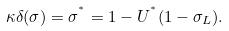Convert formula to latex. <formula><loc_0><loc_0><loc_500><loc_500>\kappa \delta ( \sigma ) = \sigma ^ { ^ { * } } = 1 - U ^ { ^ { * } } ( 1 - \sigma _ { L } ) .</formula> 